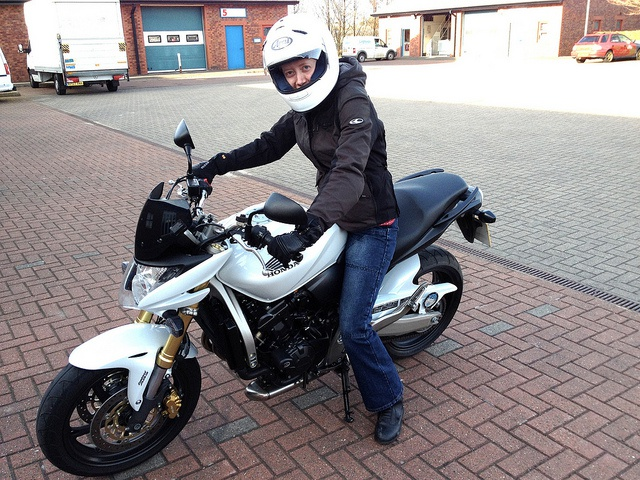Describe the objects in this image and their specific colors. I can see motorcycle in black, white, gray, and darkgray tones, people in black, navy, white, and gray tones, truck in black, white, gray, and darkgray tones, car in black, ivory, lightpink, khaki, and salmon tones, and truck in black, white, gray, and darkgray tones in this image. 